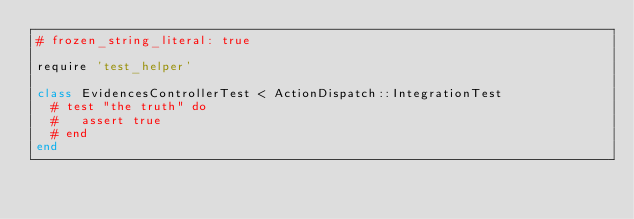<code> <loc_0><loc_0><loc_500><loc_500><_Ruby_># frozen_string_literal: true

require 'test_helper'

class EvidencesControllerTest < ActionDispatch::IntegrationTest
  # test "the truth" do
  #   assert true
  # end
end
</code> 